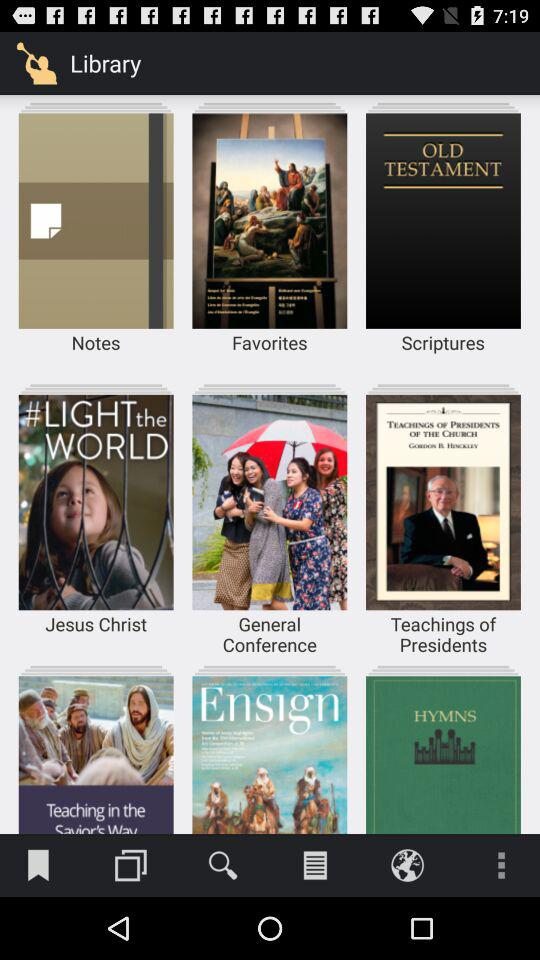Which are the folders in the library? The folders are "Notes", "Favorites", "Scriptures", "Jesus Christ", "General Conference" and "Teachings of Presidents". 